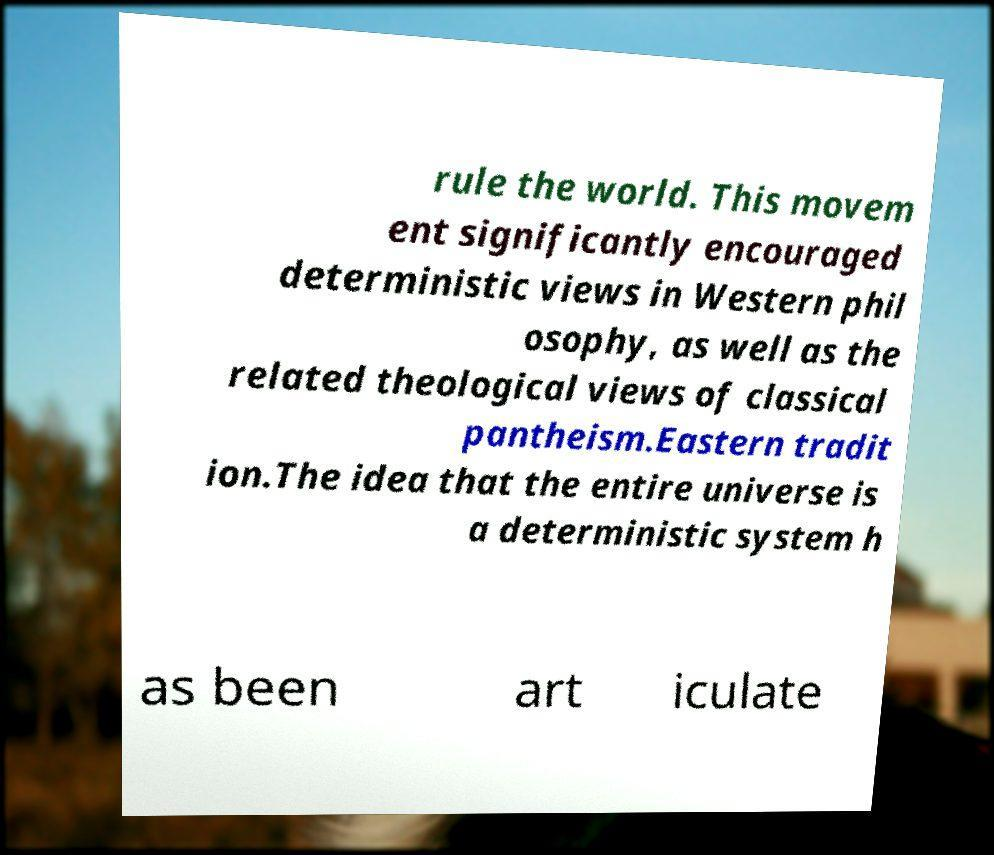Can you read and provide the text displayed in the image?This photo seems to have some interesting text. Can you extract and type it out for me? rule the world. This movem ent significantly encouraged deterministic views in Western phil osophy, as well as the related theological views of classical pantheism.Eastern tradit ion.The idea that the entire universe is a deterministic system h as been art iculate 